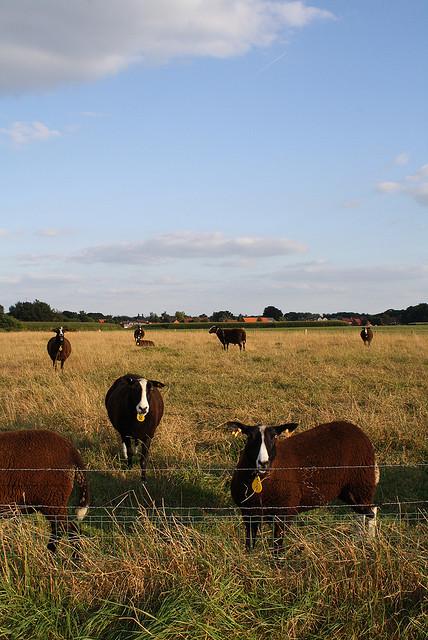Why do the cows have tags?
Give a very brief answer. Identification. What colors are the cows?
Write a very short answer. Brown. Are these cows?
Give a very brief answer. No. 